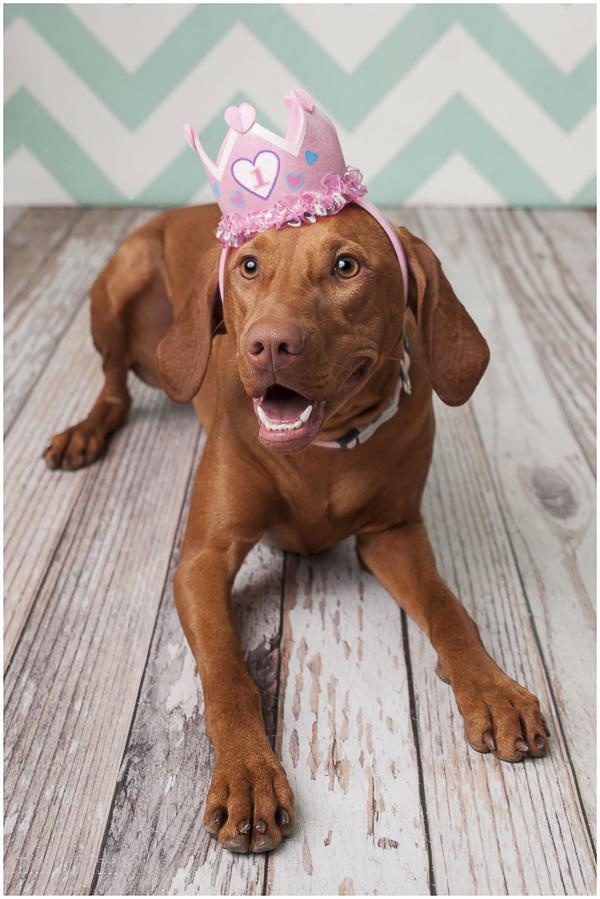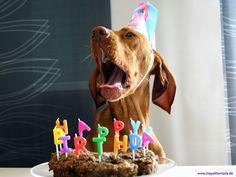The first image is the image on the left, the second image is the image on the right. Given the left and right images, does the statement "At least one of the images has a cake in front of the dog." hold true? Answer yes or no. Yes. 